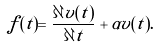Convert formula to latex. <formula><loc_0><loc_0><loc_500><loc_500>f ( t ) = \frac { \partial v ( t ) } { \partial t } + \alpha v ( t ) .</formula> 